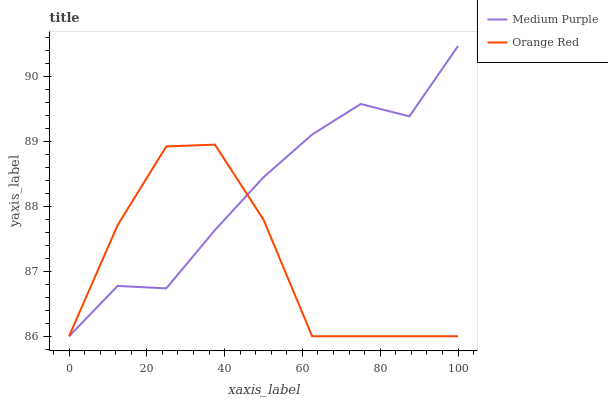Does Orange Red have the maximum area under the curve?
Answer yes or no. No. Is Orange Red the smoothest?
Answer yes or no. No. Does Orange Red have the highest value?
Answer yes or no. No. 